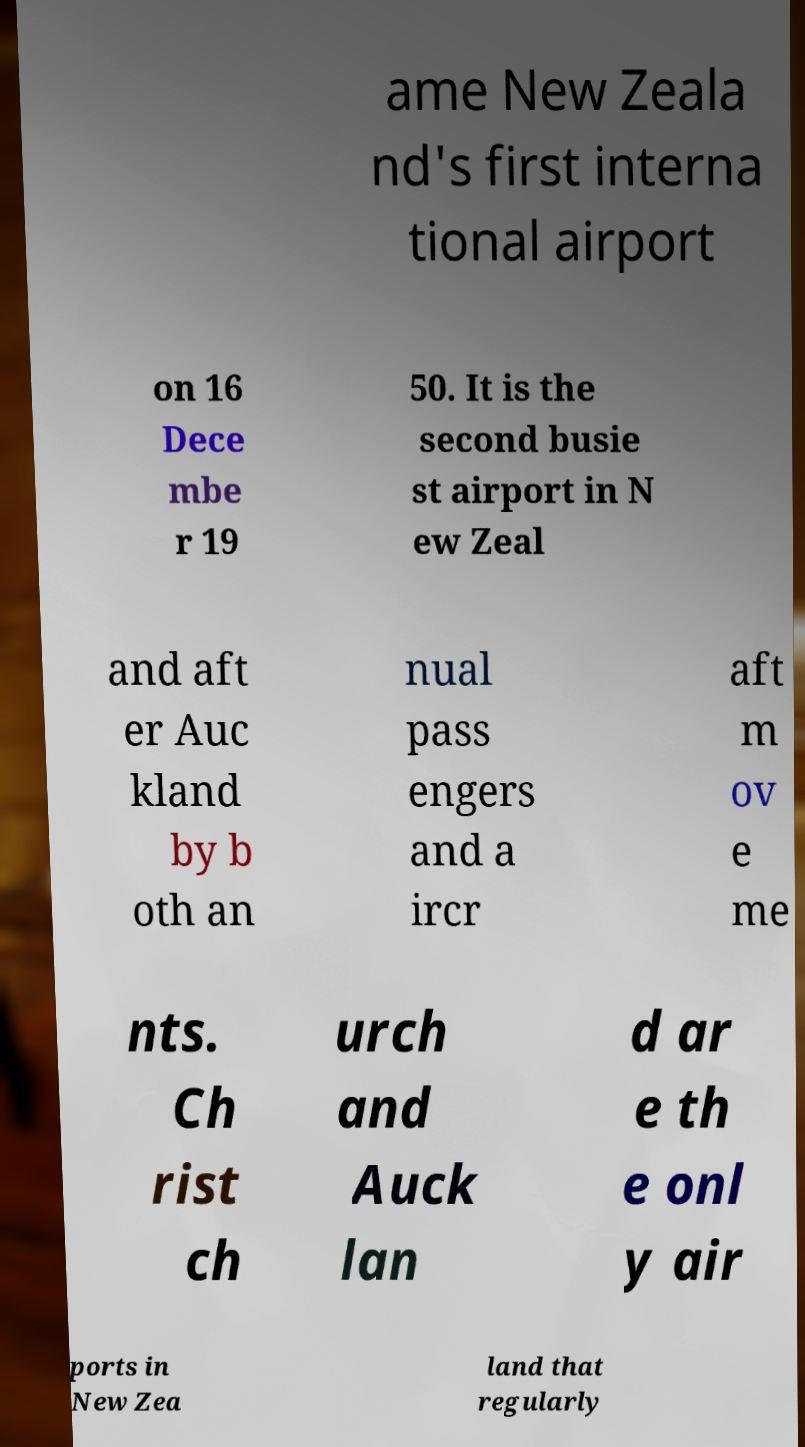Could you extract and type out the text from this image? ame New Zeala nd's first interna tional airport on 16 Dece mbe r 19 50. It is the second busie st airport in N ew Zeal and aft er Auc kland by b oth an nual pass engers and a ircr aft m ov e me nts. Ch rist ch urch and Auck lan d ar e th e onl y air ports in New Zea land that regularly 